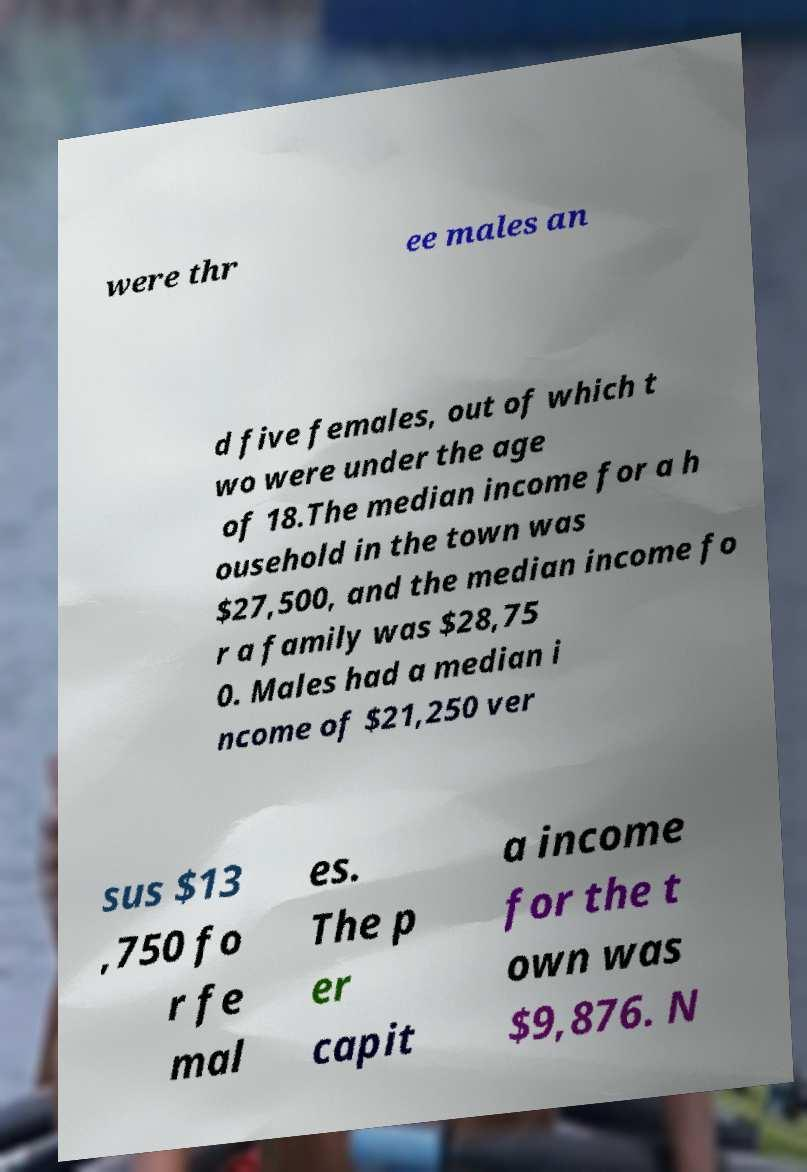Please identify and transcribe the text found in this image. were thr ee males an d five females, out of which t wo were under the age of 18.The median income for a h ousehold in the town was $27,500, and the median income fo r a family was $28,75 0. Males had a median i ncome of $21,250 ver sus $13 ,750 fo r fe mal es. The p er capit a income for the t own was $9,876. N 